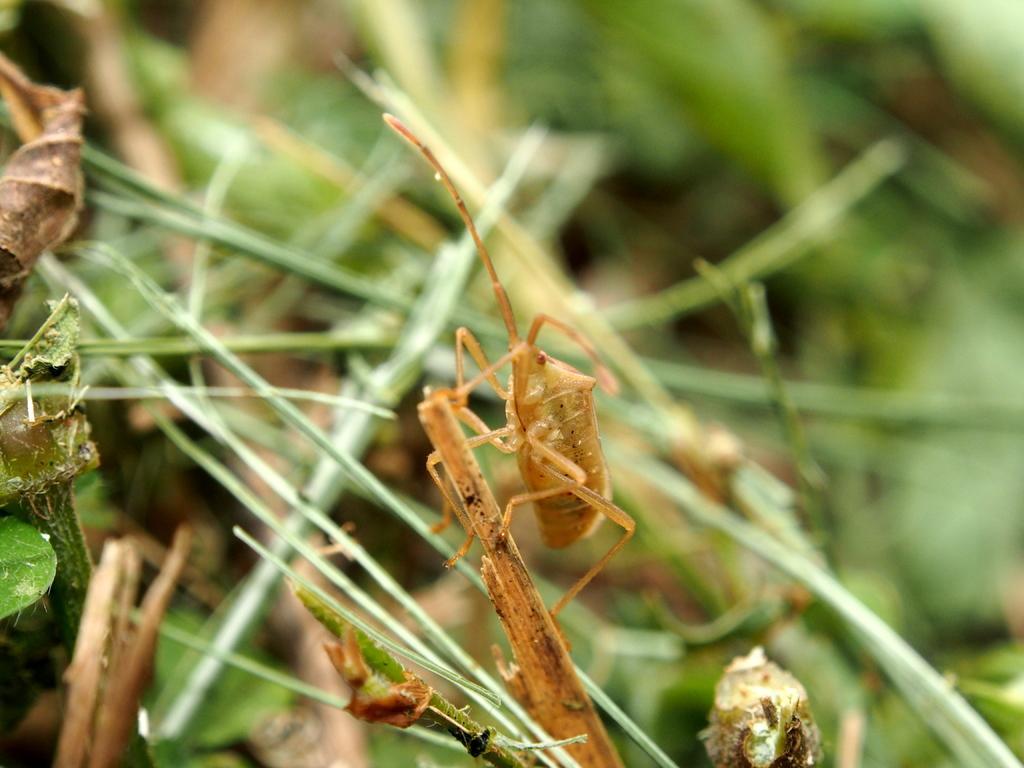Describe this image in one or two sentences. In this image I can see a stick on which there is a brown color insect. In the background I can see the stems and I see that it is blurred in the background. 